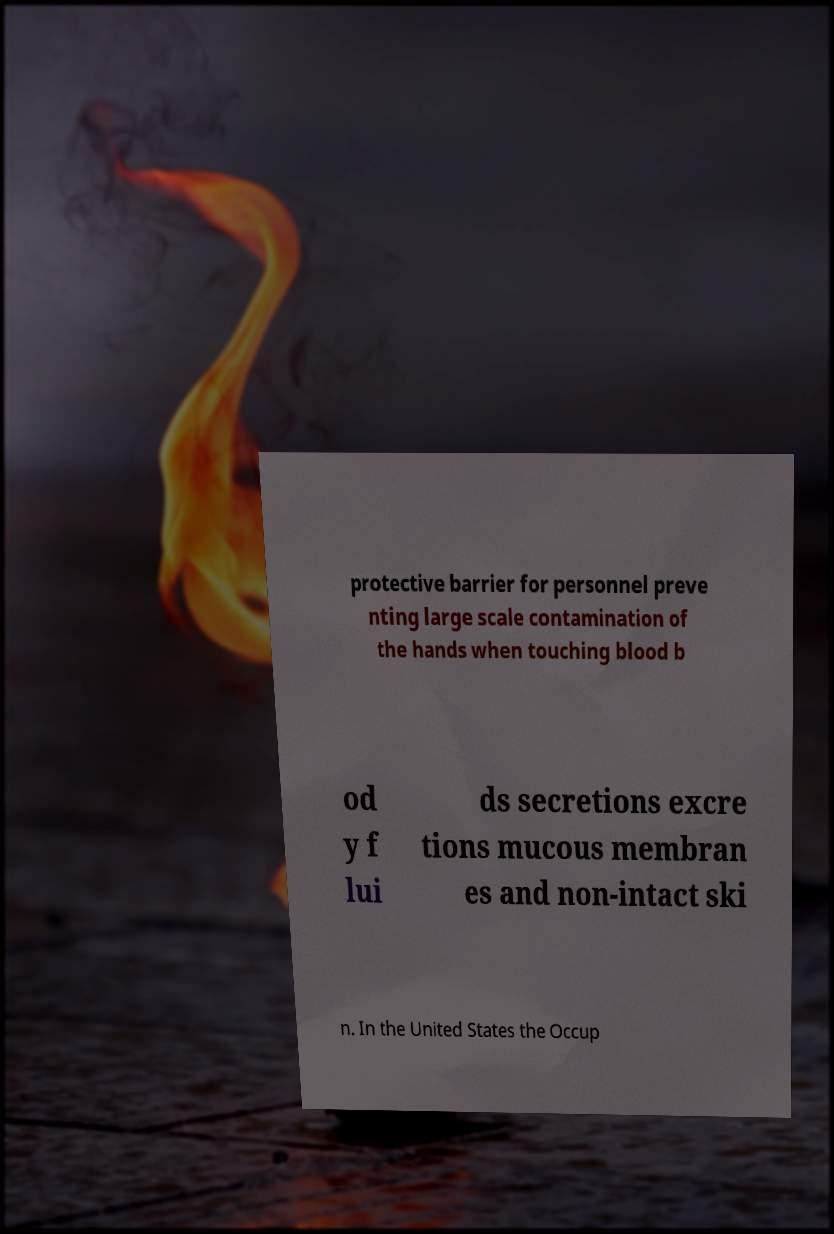Please identify and transcribe the text found in this image. protective barrier for personnel preve nting large scale contamination of the hands when touching blood b od y f lui ds secretions excre tions mucous membran es and non-intact ski n. In the United States the Occup 